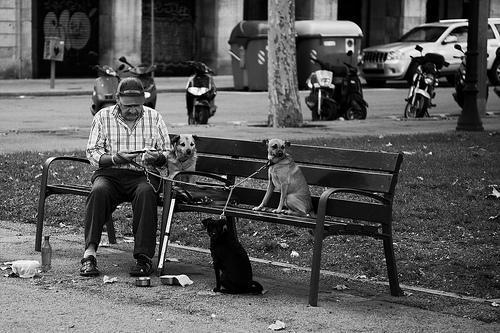How many dogs are on he bench in this image?
Give a very brief answer. 2. How many black dogs are in the image?
Give a very brief answer. 1. 